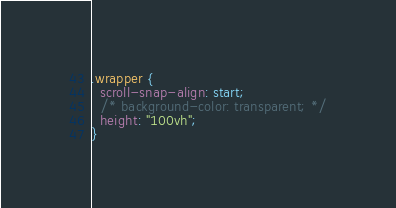Convert code to text. <code><loc_0><loc_0><loc_500><loc_500><_CSS_>

.wrapper {
  scroll-snap-align: start;
  /* background-color: transparent; */
  height: "100vh";
}

</code> 